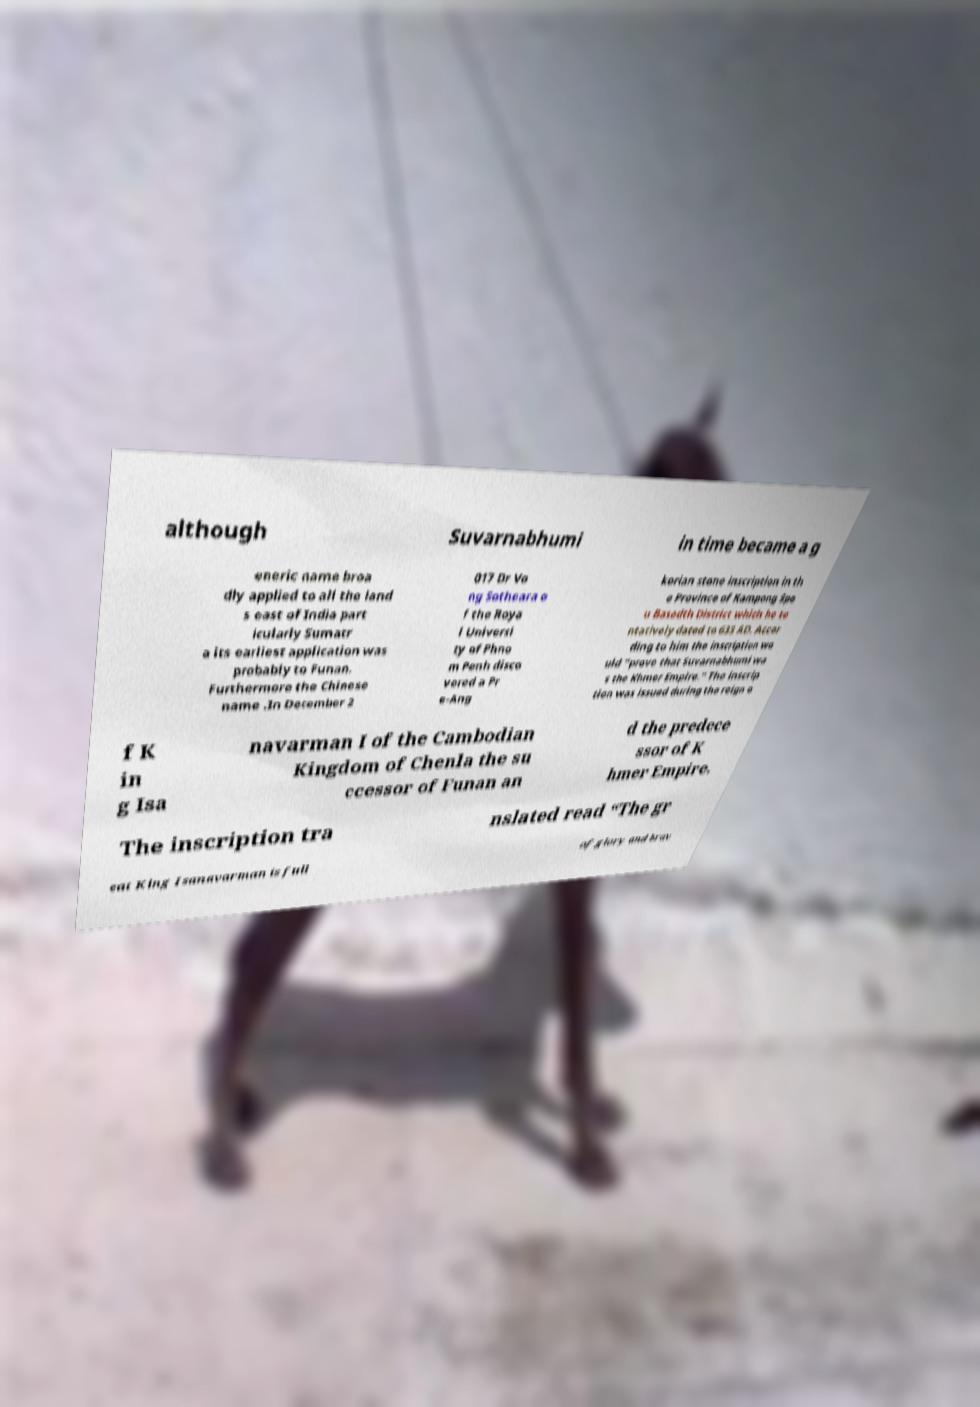Can you read and provide the text displayed in the image?This photo seems to have some interesting text. Can you extract and type it out for me? although Suvarnabhumi in time became a g eneric name broa dly applied to all the land s east of India part icularly Sumatr a its earliest application was probably to Funan. Furthermore the Chinese name .In December 2 017 Dr Vo ng Sotheara o f the Roya l Universi ty of Phno m Penh disco vered a Pr e-Ang korian stone inscription in th e Province of Kampong Spe u Basedth District which he te ntatively dated to 633 AD. Accor ding to him the inscription wo uld “prove that Suvarnabhumi wa s the Khmer Empire.” The inscrip tion was issued during the reign o f K in g Isa navarman I of the Cambodian Kingdom of Chenla the su ccessor of Funan an d the predece ssor of K hmer Empire. The inscription tra nslated read “The gr eat King Isanavarman is full of glory and brav 